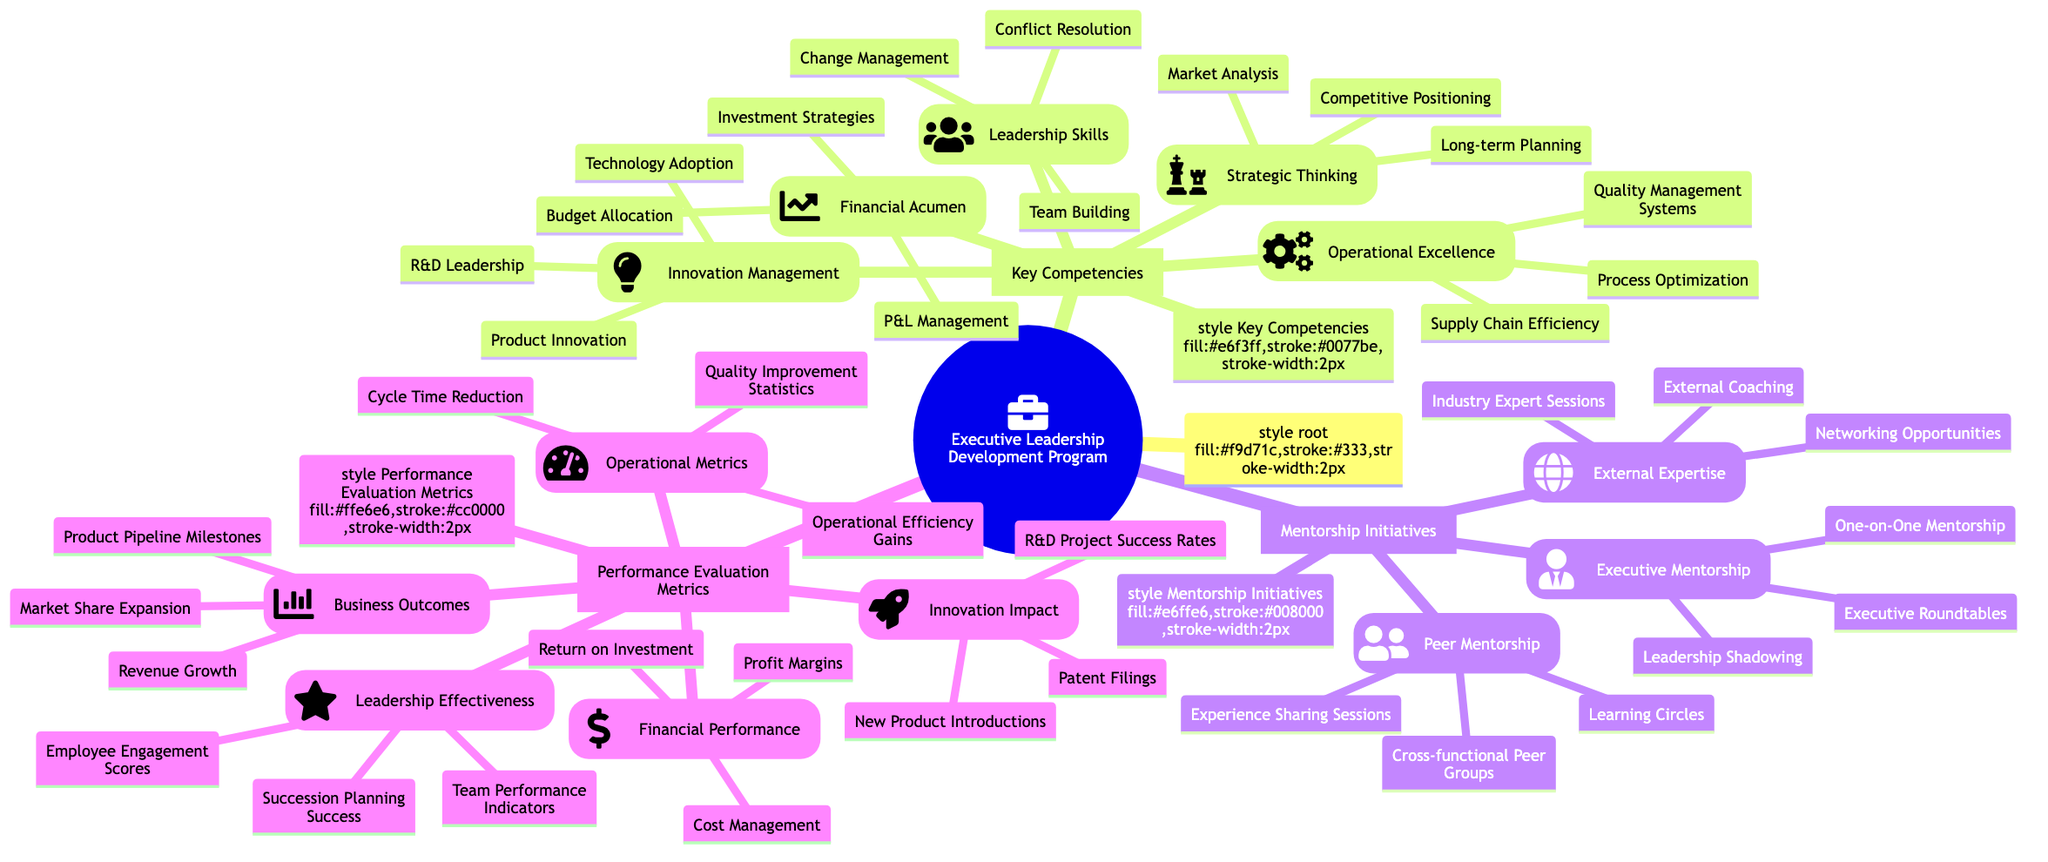What's the total number of key competencies listed? The diagram shows five main categories of key competencies under the "Key Competencies" node, which are Strategic Thinking, Innovation Management, Financial Acumen, Operational Excellence, and Leadership Skills. Therefore, the total number is 5.
Answer: 5 Which mentorship initiative involves one-on-one interactions? Under the "Mentorship Initiatives" section, "Executive Mentorship" includes a specific initiative called "One-on-One Mentorship," which indicates it is the initiative focusing on individual interactions.
Answer: One-on-One Mentorship How many operational metrics are included? In the "Performance Evaluation Metrics" section, there is a category called "Operational Metrics," which lists three specific metrics: Cycle Time Reduction, Quality Improvement Statistics, and Operational Efficiency Gains. This indicates that there are 3 operational metrics in total.
Answer: 3 What is the relationship between Strategic Thinking and Competitive Positioning? Competitive Positioning is listed as one of the elements under the Strategic Thinking category in the Key Competencies. This shows that Competitive Positioning is a specific aspect or component of Strategic Thinking.
Answer: Competitive Positioning is part of Strategic Thinking Which initiative under Peer Mentorship focuses on sharing experiences? The initiative titled "Experience Sharing Sessions" is listed under the "Peer Mentorship" category, indicating that it focuses specifically on sharing experiences among peers.
Answer: Experience Sharing Sessions What is the primary metric for Leadership Effectiveness? The primary metrics listed under "Leadership Effectiveness" include Employee Engagement Scores, Team Performance Indicators, and Succession Planning Success. Hence, one could argue that all three are primary metrics, but the first one listed is "Employee Engagement Scores."
Answer: Employee Engagement Scores What type of expertise is highlighted in the External Expertise category? The category "External Expertise" discusses three initiatives: Industry Expert Sessions, External Coaching, and Networking Opportunities, all of which encapsulate the concept of engaging with individuals outside the organization for guidance and insights.
Answer: Industry Expert Sessions How many components are there under Business Outcomes? Under the "Performance Evaluation Metrics" section, the "Business Outcomes" category includes three components: Revenue Growth, Market Share Expansion, and Product Pipeline Milestones. Thus, there are 3 components under Business Outcomes.
Answer: 3 